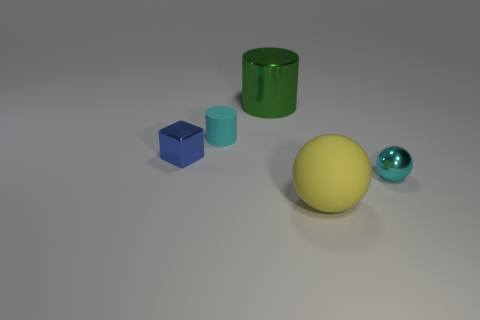What size is the ball that is the same color as the tiny rubber cylinder?
Your response must be concise. Small. What is the material of the tiny cylinder that is the same color as the tiny shiny sphere?
Your response must be concise. Rubber. What shape is the small blue object?
Offer a terse response. Cube. There is a thing that is to the right of the rubber object in front of the tiny block; what is its color?
Ensure brevity in your answer.  Cyan. There is a ball behind the big matte thing; what is its size?
Your answer should be very brief. Small. Are there any gray cubes that have the same material as the tiny blue cube?
Offer a very short reply. No. How many large gray metal things are the same shape as the tiny matte object?
Give a very brief answer. 0. There is a tiny shiny object to the left of the cyan object that is in front of the metallic object left of the tiny matte cylinder; what is its shape?
Your answer should be very brief. Cube. What is the small thing that is both in front of the small cyan matte cylinder and to the left of the metal ball made of?
Provide a succinct answer. Metal. Do the rubber object in front of the cyan ball and the big green thing have the same size?
Provide a short and direct response. Yes. 